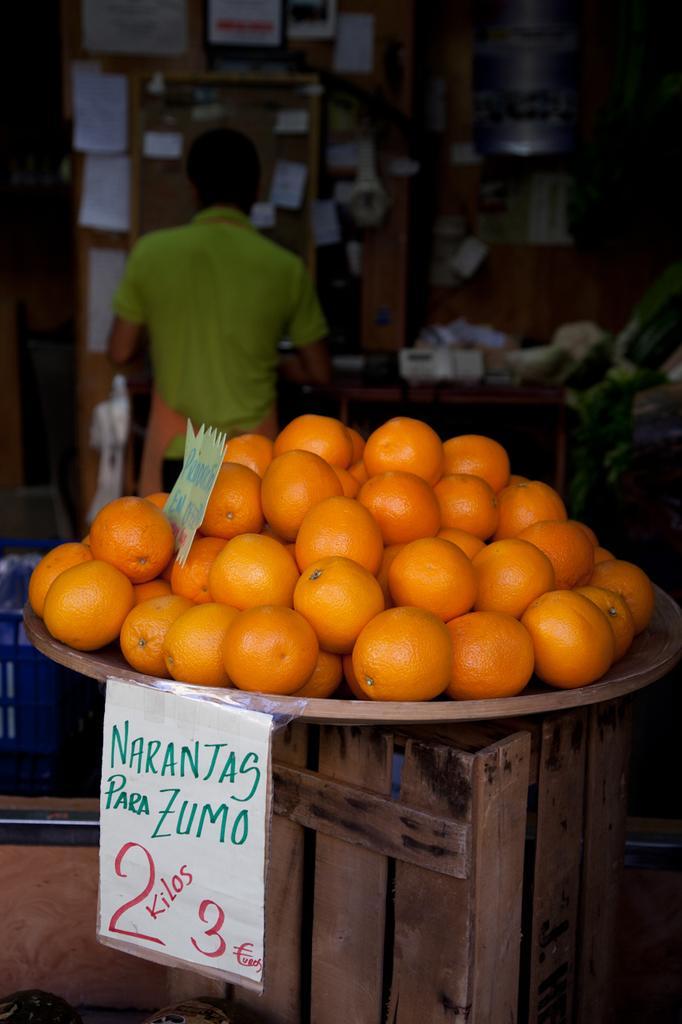In one or two sentences, can you explain what this image depicts? In this image, in the middle, we can see a wooden box, on the box, we can see a plate with some oranges. On the left side, we can also see a paper, on the paper, we can see some text written on it. In the background, we can see a man standing in front of the stall. On the stall, we can see some papers attached to it and a table with some object. 